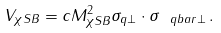<formula> <loc_0><loc_0><loc_500><loc_500>V _ { \chi S B } = c M ^ { 2 } _ { \chi S B } { \sigma _ { q \perp } \cdot \sigma _ { \ q b a r \perp } } \, .</formula> 